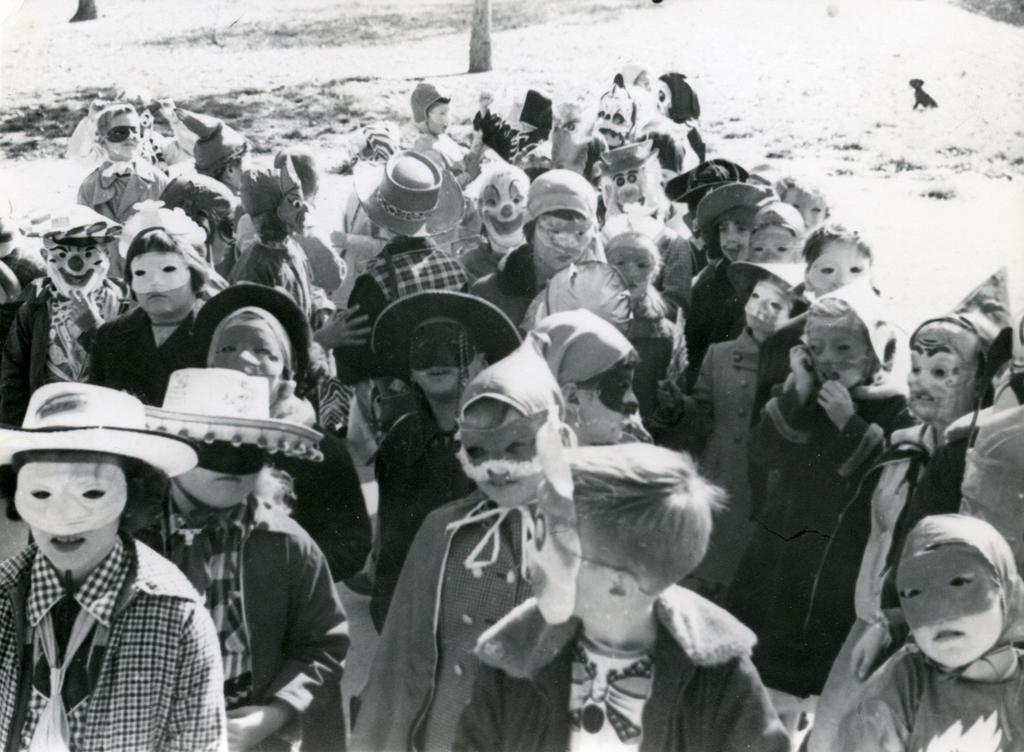In one or two sentences, can you explain what this image depicts? It is a black and white image. In this image we can see the people with the masks. In the background we can see the tree barks. 